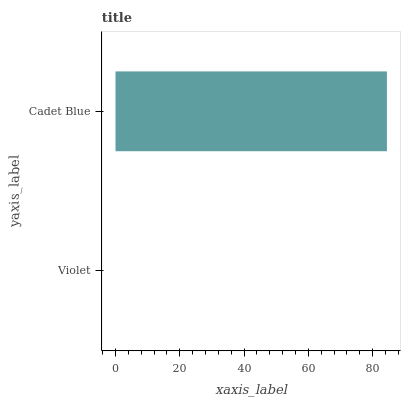Is Violet the minimum?
Answer yes or no. Yes. Is Cadet Blue the maximum?
Answer yes or no. Yes. Is Cadet Blue the minimum?
Answer yes or no. No. Is Cadet Blue greater than Violet?
Answer yes or no. Yes. Is Violet less than Cadet Blue?
Answer yes or no. Yes. Is Violet greater than Cadet Blue?
Answer yes or no. No. Is Cadet Blue less than Violet?
Answer yes or no. No. Is Cadet Blue the high median?
Answer yes or no. Yes. Is Violet the low median?
Answer yes or no. Yes. Is Violet the high median?
Answer yes or no. No. Is Cadet Blue the low median?
Answer yes or no. No. 